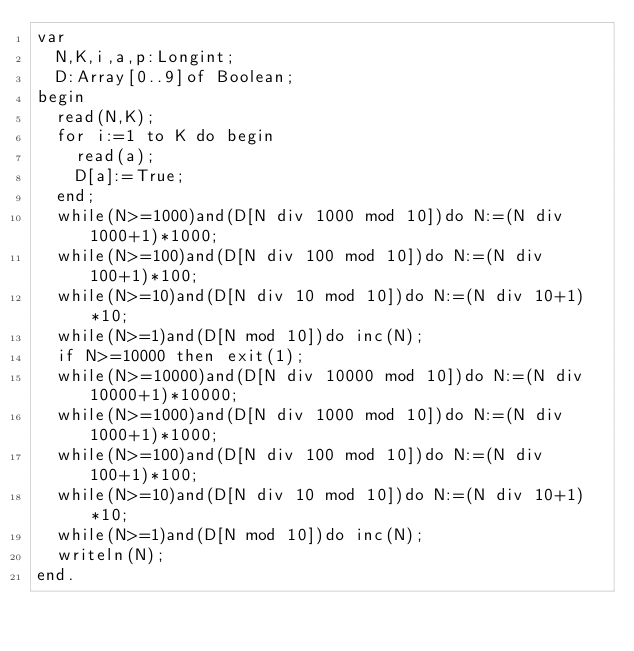<code> <loc_0><loc_0><loc_500><loc_500><_Pascal_>var
	N,K,i,a,p:Longint;
	D:Array[0..9]of Boolean;
begin
	read(N,K);
	for i:=1 to K do begin
		read(a);
		D[a]:=True;
	end;
	while(N>=1000)and(D[N div 1000 mod 10])do N:=(N div 1000+1)*1000;
	while(N>=100)and(D[N div 100 mod 10])do N:=(N div 100+1)*100;
	while(N>=10)and(D[N div 10 mod 10])do N:=(N div 10+1)*10;
	while(N>=1)and(D[N mod 10])do inc(N);
	if N>=10000 then exit(1);
	while(N>=10000)and(D[N div 10000 mod 10])do N:=(N div 10000+1)*10000;
	while(N>=1000)and(D[N div 1000 mod 10])do N:=(N div 1000+1)*1000;
	while(N>=100)and(D[N div 100 mod 10])do N:=(N div 100+1)*100;
	while(N>=10)and(D[N div 10 mod 10])do N:=(N div 10+1)*10;
	while(N>=1)and(D[N mod 10])do inc(N);
	writeln(N);
end.
</code> 